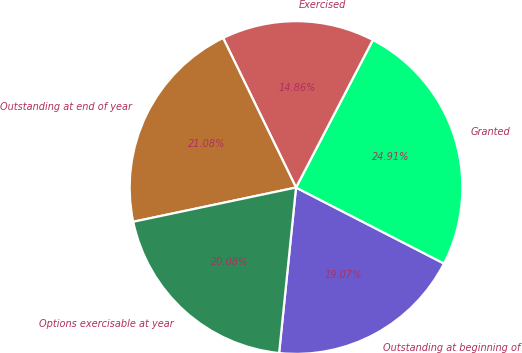Convert chart to OTSL. <chart><loc_0><loc_0><loc_500><loc_500><pie_chart><fcel>Outstanding at beginning of<fcel>Granted<fcel>Exercised<fcel>Outstanding at end of year<fcel>Options exercisable at year<nl><fcel>19.07%<fcel>24.91%<fcel>14.86%<fcel>21.08%<fcel>20.08%<nl></chart> 